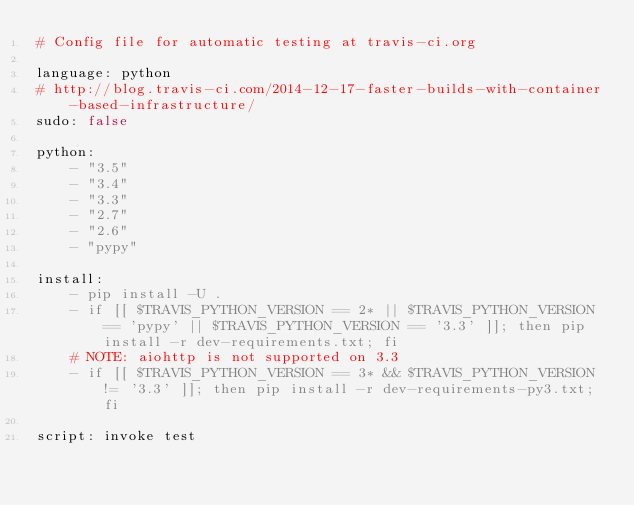Convert code to text. <code><loc_0><loc_0><loc_500><loc_500><_YAML_># Config file for automatic testing at travis-ci.org

language: python
# http://blog.travis-ci.com/2014-12-17-faster-builds-with-container-based-infrastructure/
sudo: false

python:
    - "3.5"
    - "3.4"
    - "3.3"
    - "2.7"
    - "2.6"
    - "pypy"

install:
    - pip install -U .
    - if [[ $TRAVIS_PYTHON_VERSION == 2* || $TRAVIS_PYTHON_VERSION == 'pypy' || $TRAVIS_PYTHON_VERSION == '3.3' ]]; then pip install -r dev-requirements.txt; fi
    # NOTE: aiohttp is not supported on 3.3
    - if [[ $TRAVIS_PYTHON_VERSION == 3* && $TRAVIS_PYTHON_VERSION != '3.3' ]]; then pip install -r dev-requirements-py3.txt; fi

script: invoke test
</code> 